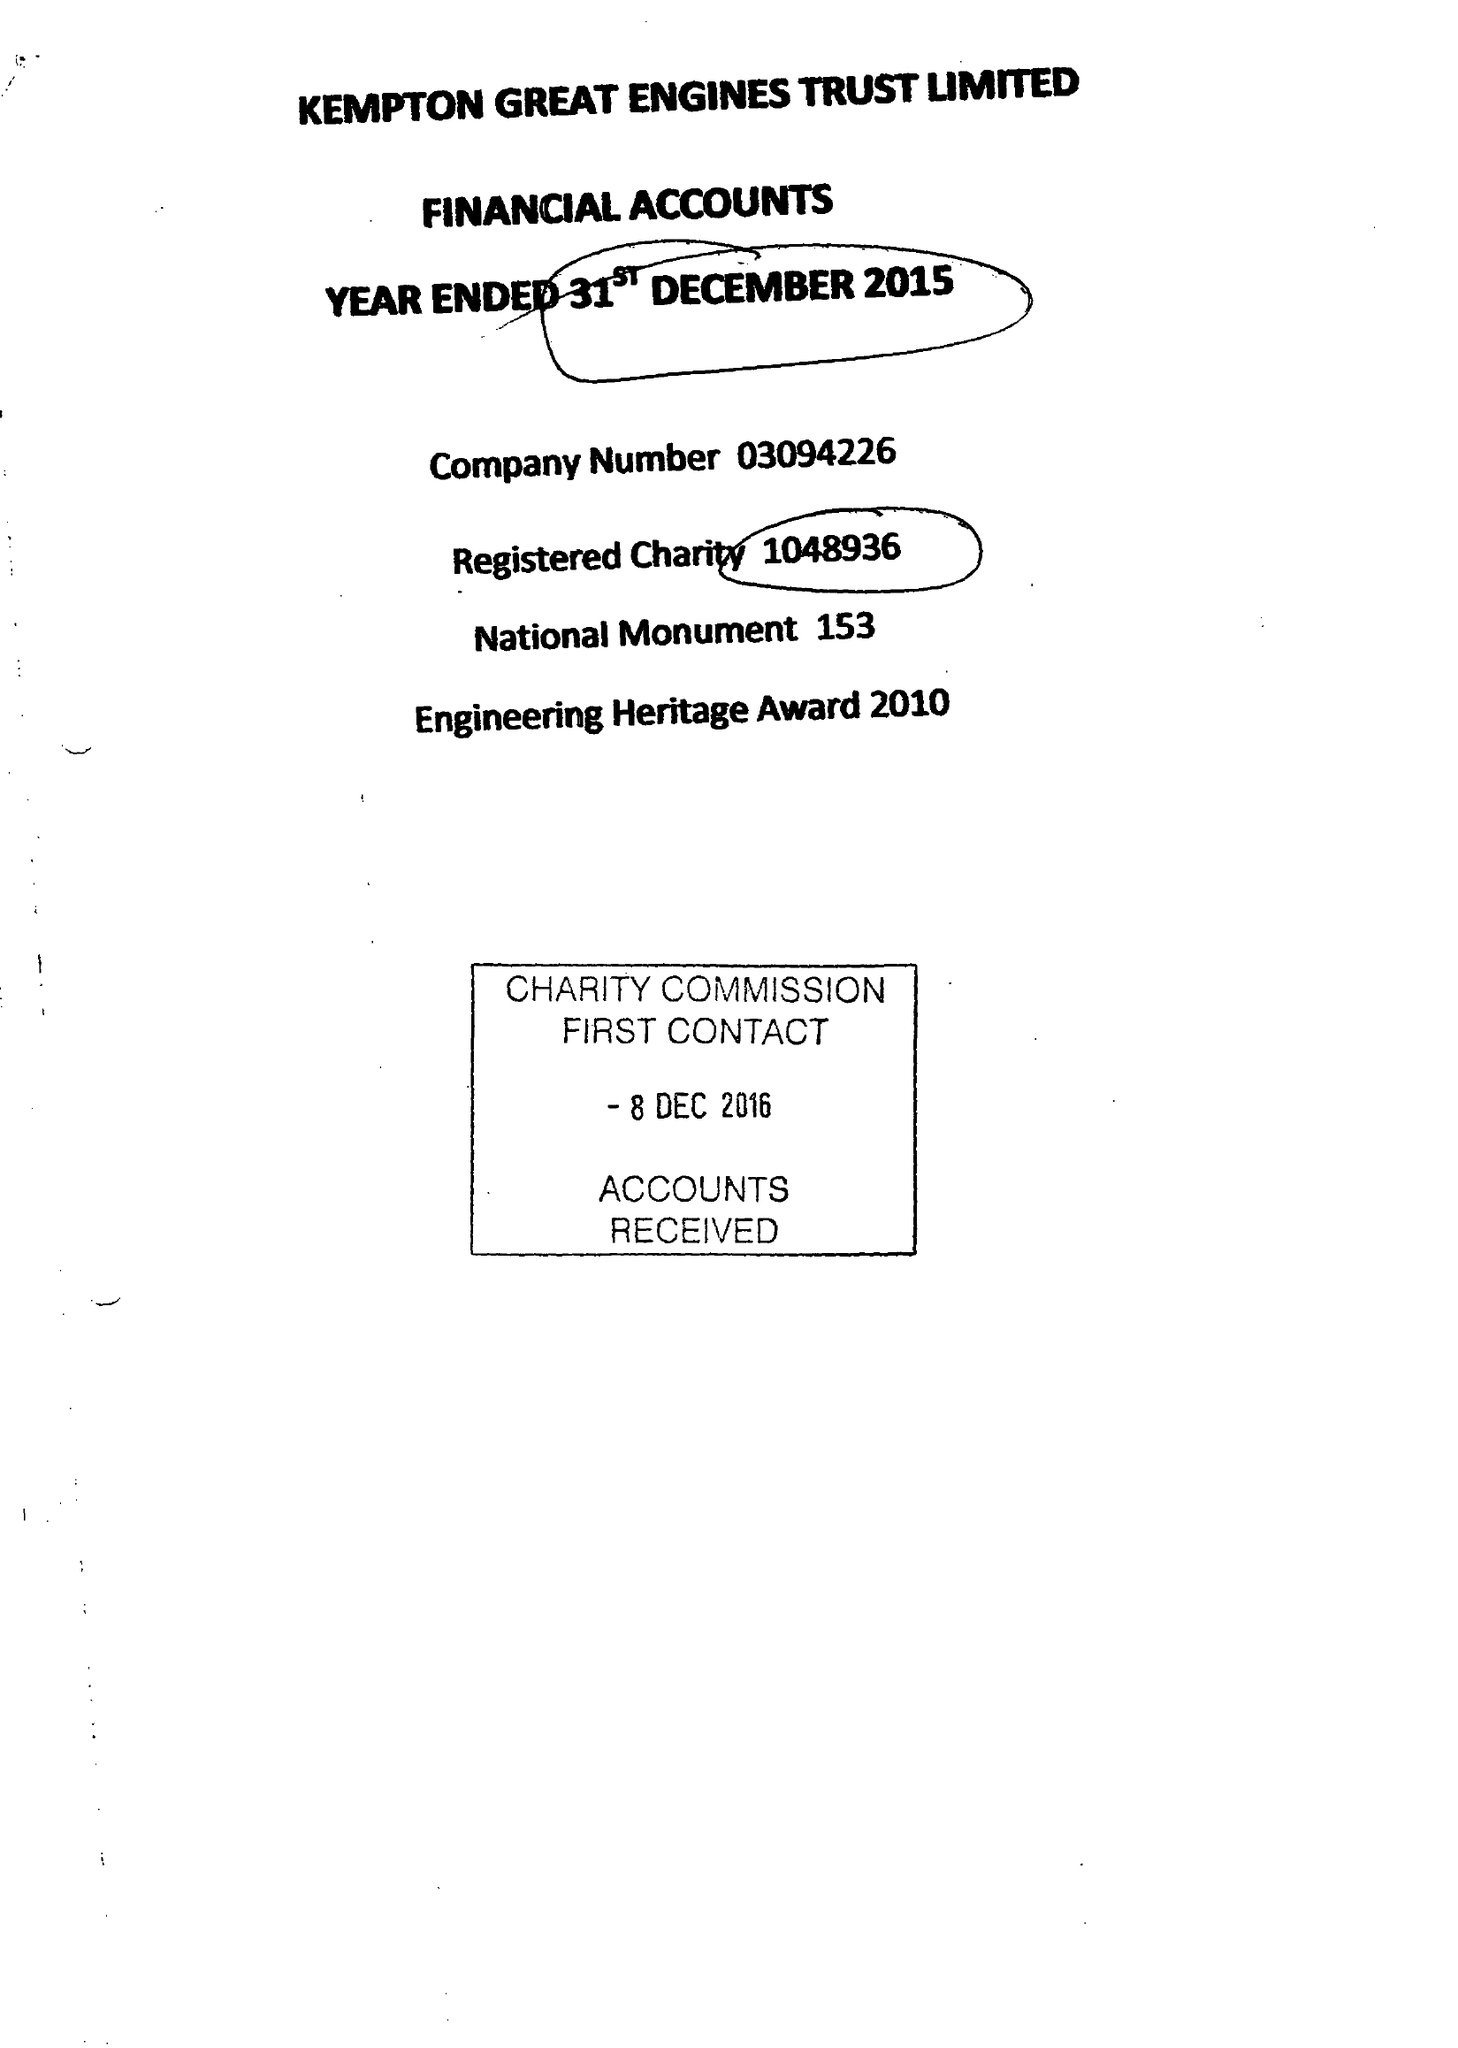What is the value for the address__post_town?
Answer the question using a single word or phrase. FELTHAM 